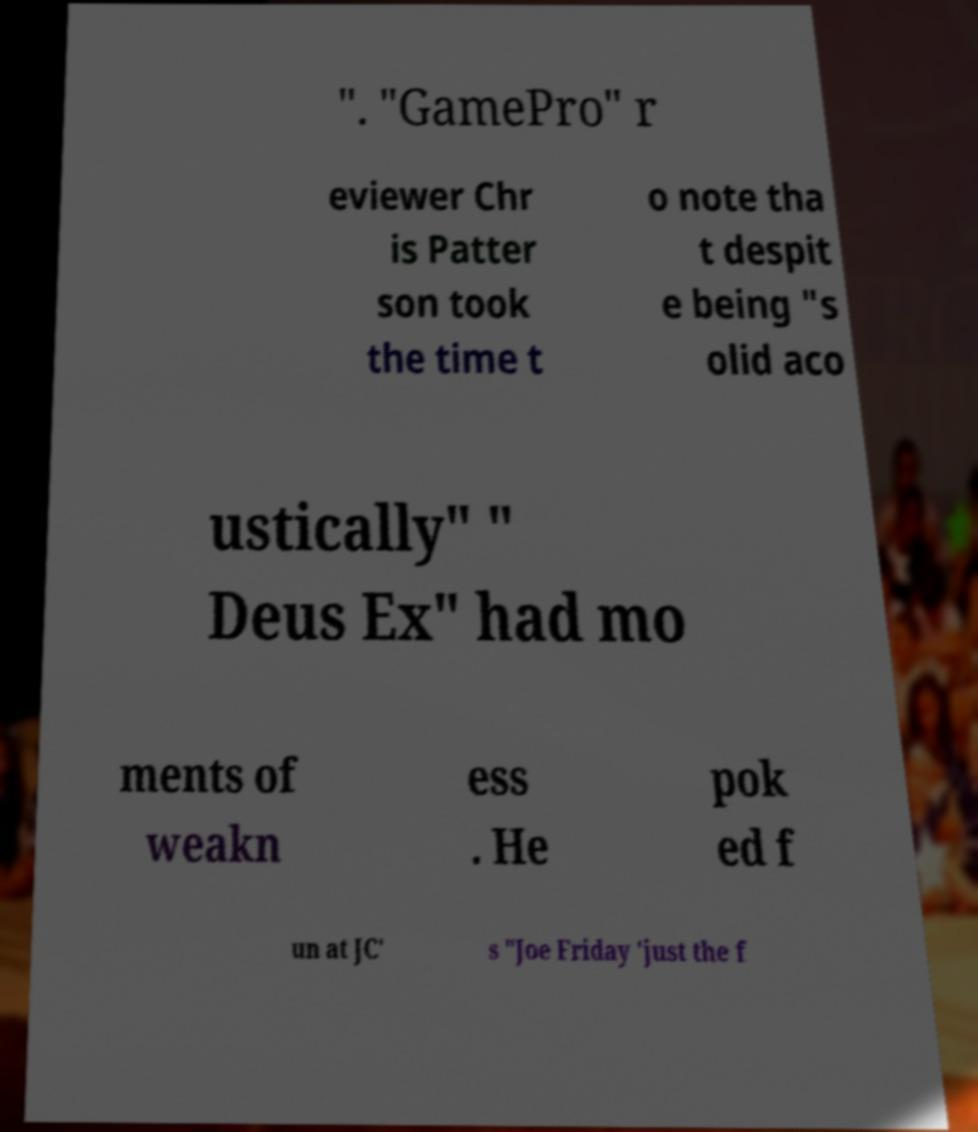For documentation purposes, I need the text within this image transcribed. Could you provide that? ". "GamePro" r eviewer Chr is Patter son took the time t o note tha t despit e being "s olid aco ustically" " Deus Ex" had mo ments of weakn ess . He pok ed f un at JC' s "Joe Friday 'just the f 